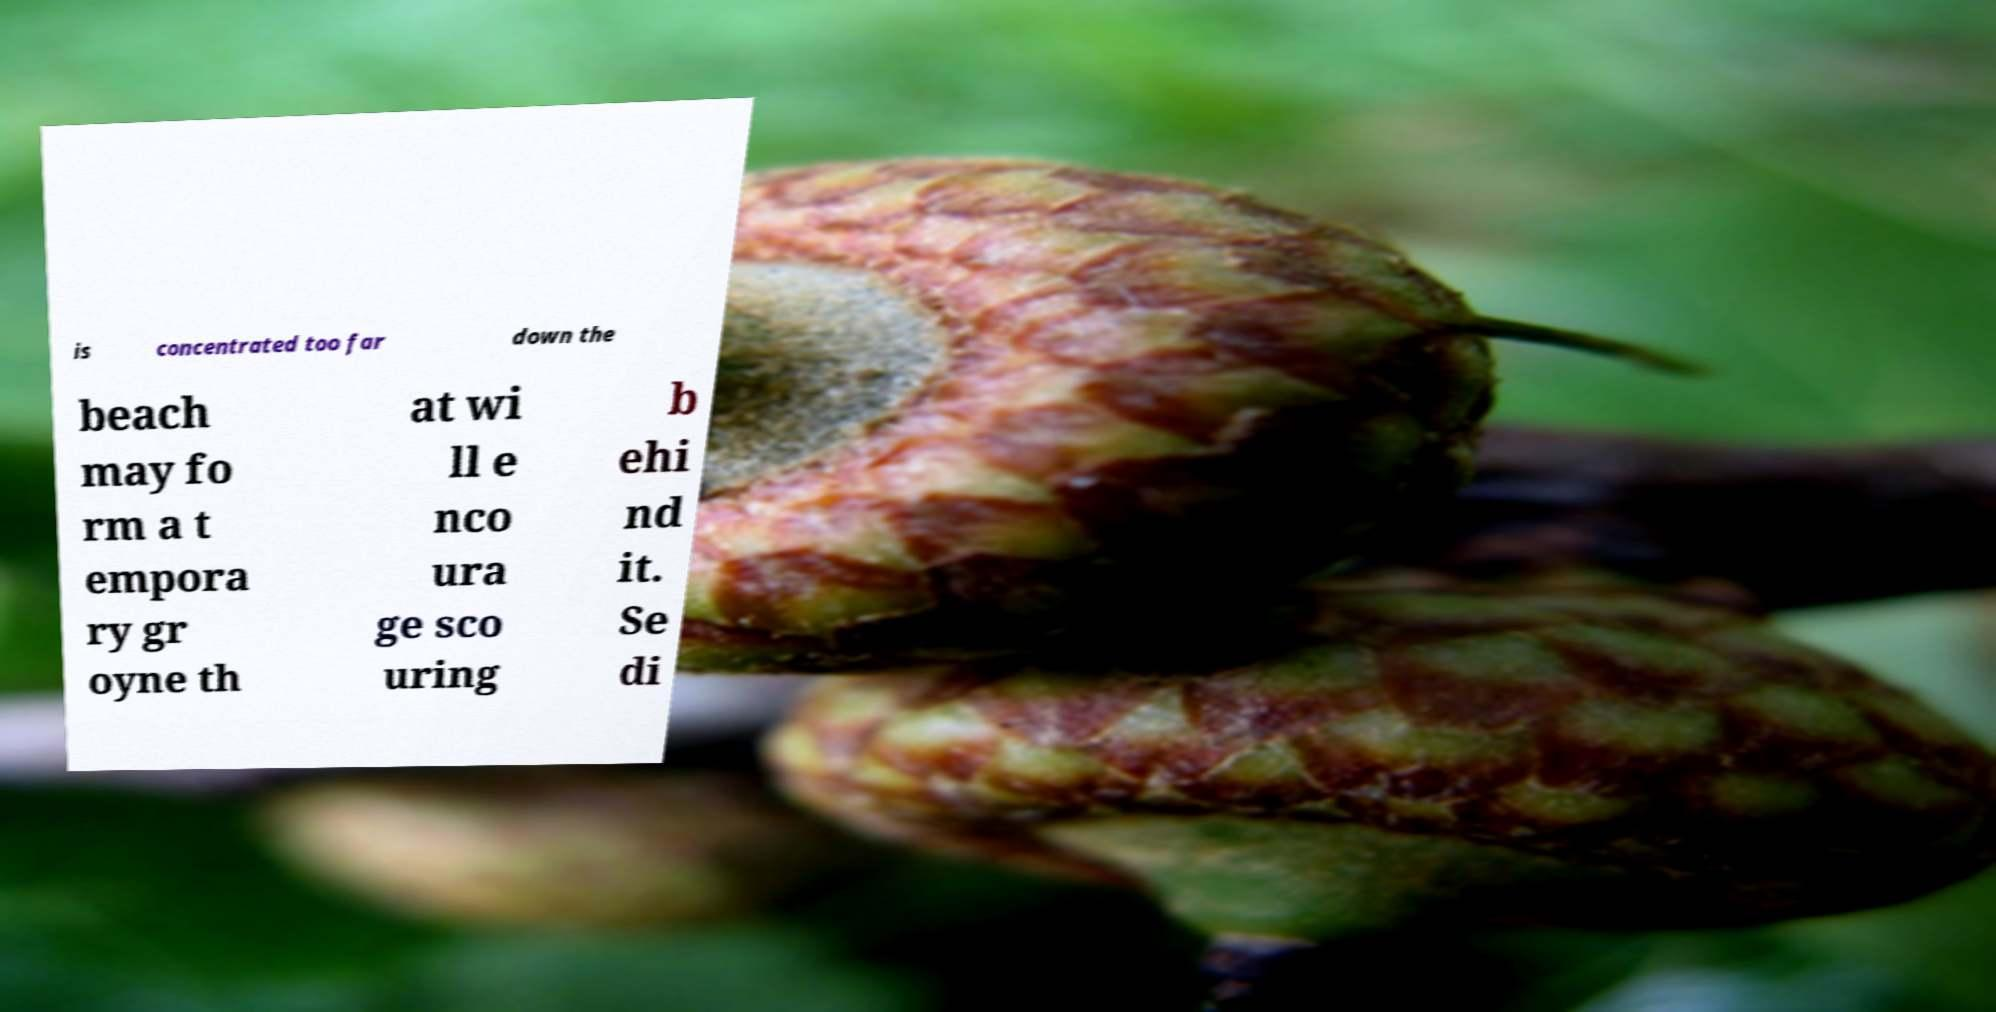I need the written content from this picture converted into text. Can you do that? is concentrated too far down the beach may fo rm a t empora ry gr oyne th at wi ll e nco ura ge sco uring b ehi nd it. Se di 